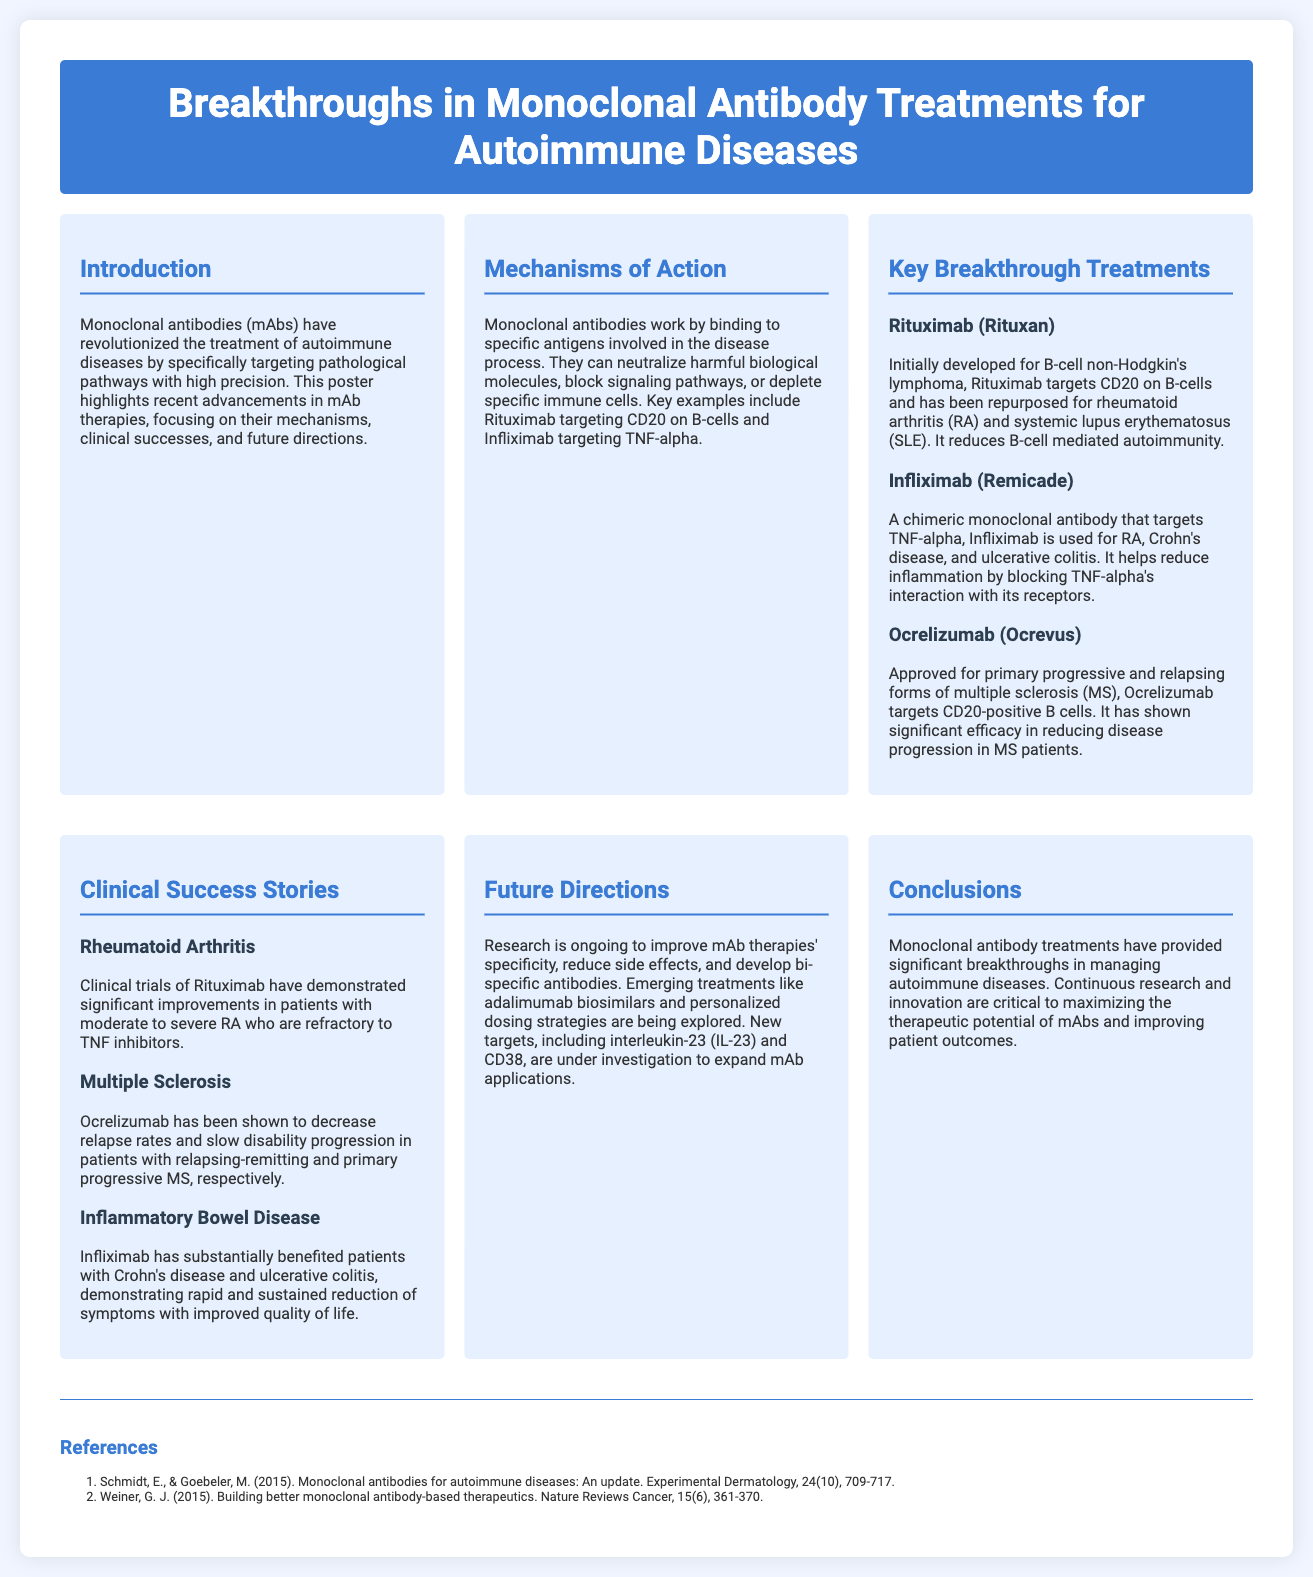What is the primary focus of the poster? The primary focus of the poster is to highlight recent advancements in monoclonal antibody therapies for autoimmune diseases.
Answer: advancements in monoclonal antibody therapies for autoimmune diseases Which monoclonal antibody targets CD20 on B-cells? Rituximab is the monoclonal antibody that targets CD20 on B-cells.
Answer: Rituximab What diseases is Infliximab used to treat? Infliximab is used for rheumatoid arthritis, Crohn's disease, and ulcerative colitis.
Answer: rheumatoid arthritis, Crohn's disease, and ulcerative colitis What is the role of Ocrelizumab in multiple sclerosis treatment? Ocrelizumab targets CD20-positive B cells and has shown significant efficacy in reducing disease progression in MS patients.
Answer: reducing disease progression in MS patients What is being explored in future directions for mAb therapies? Research is ongoing to improve specificity, reduce side effects, and develop bi-specific antibodies.
Answer: improve specificity, reduce side effects, and develop bi-specific antibodies Which autoimmune disease shows clinical improvement with Rituximab? Clinical trials have demonstrated significant improvements in patients with moderate to severe rheumatoid arthritis who are refractory to TNF inhibitors.
Answer: rheumatoid arthritis What are new targets under investigation for mAb therapies? New targets under investigation include interleukin-23 (IL-23) and CD38.
Answer: interleukin-23 (IL-23) and CD38 What type of content is found in the references section? The references section includes citations of studies and reviews related to monoclonal antibodies for autoimmune diseases.
Answer: citations of studies and reviews What is the color theme of the poster? The poster features a color theme of white and shades of blue.
Answer: white and shades of blue 